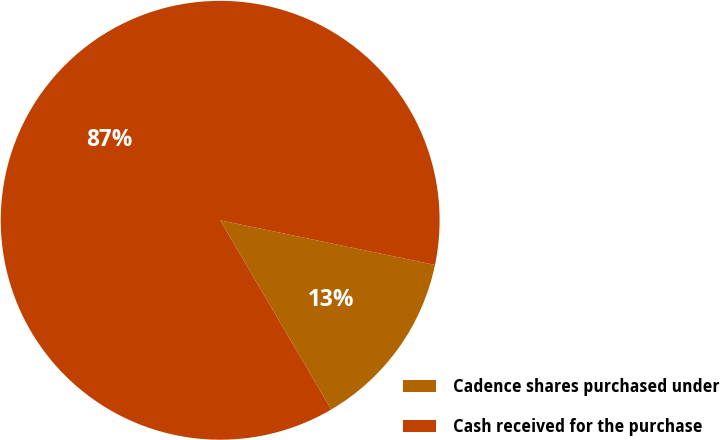<chart> <loc_0><loc_0><loc_500><loc_500><pie_chart><fcel>Cadence shares purchased under<fcel>Cash received for the purchase<nl><fcel>13.29%<fcel>86.71%<nl></chart> 